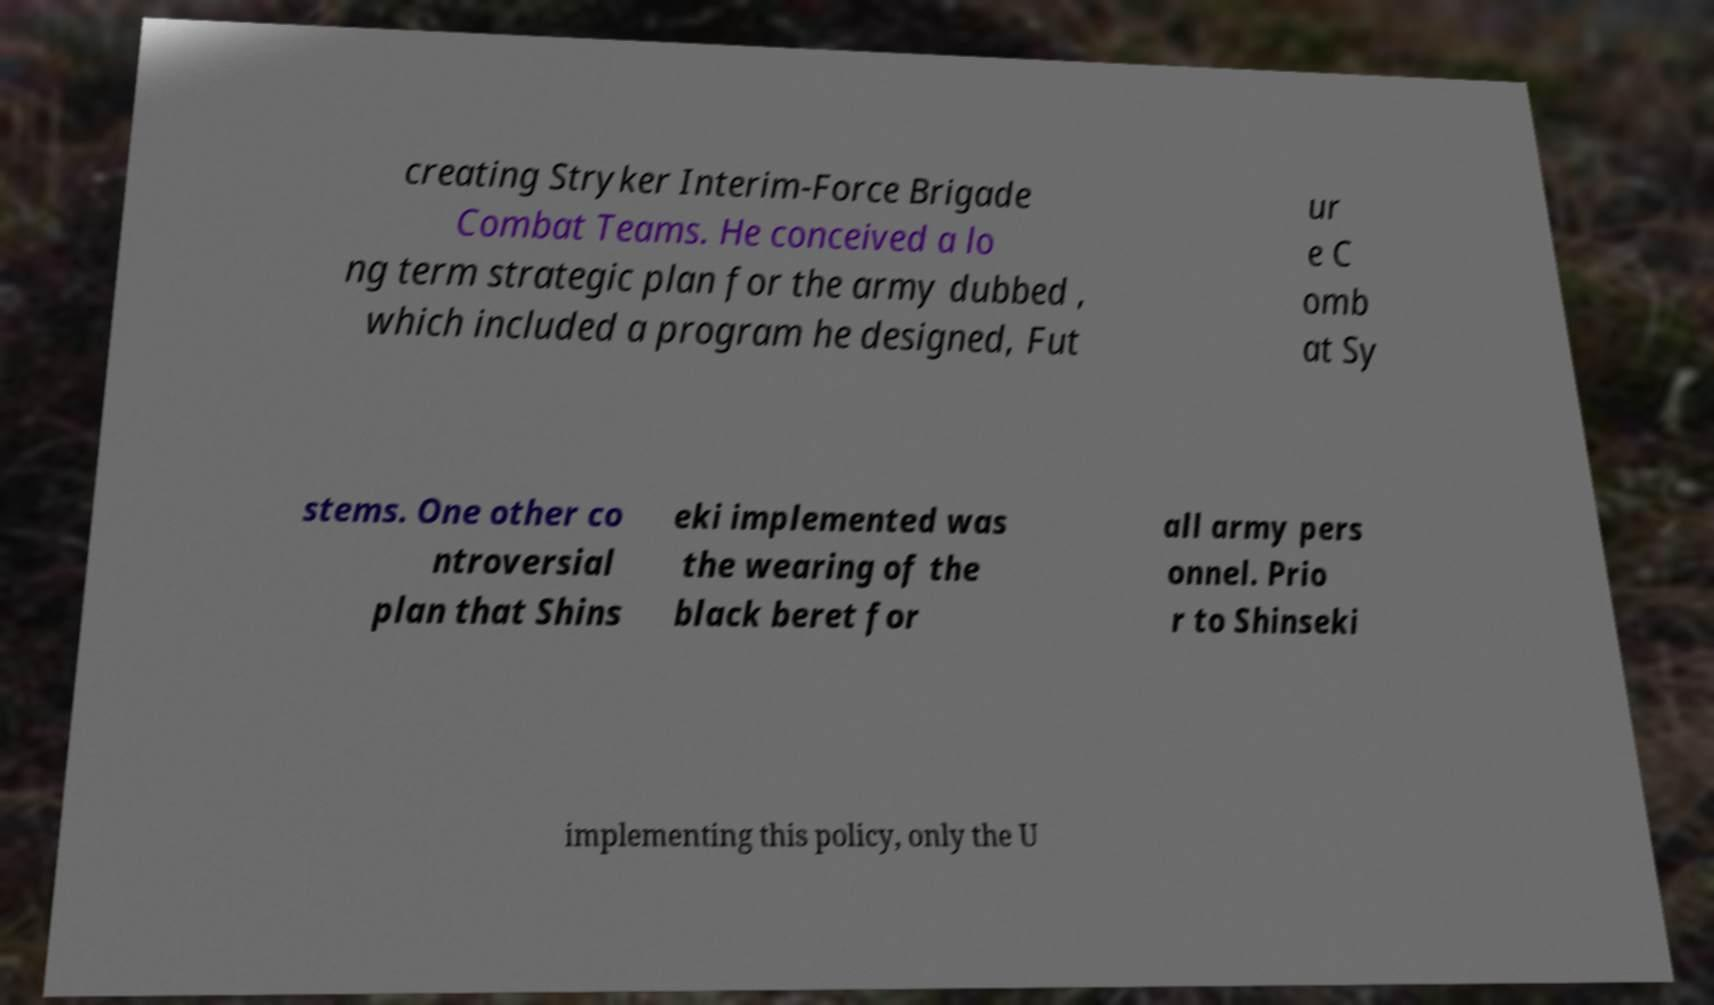What messages or text are displayed in this image? I need them in a readable, typed format. creating Stryker Interim-Force Brigade Combat Teams. He conceived a lo ng term strategic plan for the army dubbed , which included a program he designed, Fut ur e C omb at Sy stems. One other co ntroversial plan that Shins eki implemented was the wearing of the black beret for all army pers onnel. Prio r to Shinseki implementing this policy, only the U 